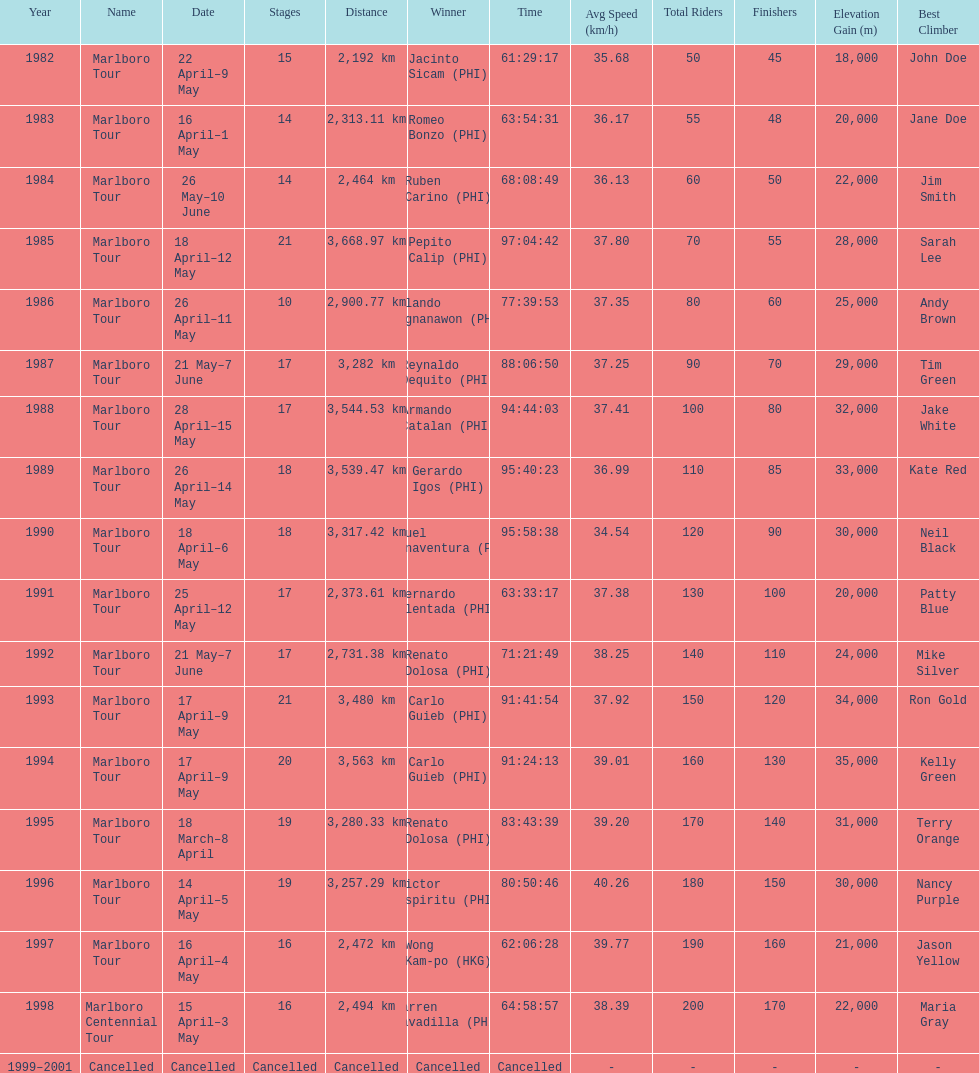Who is listed before wong kam-po? Victor Espiritu (PHI). 